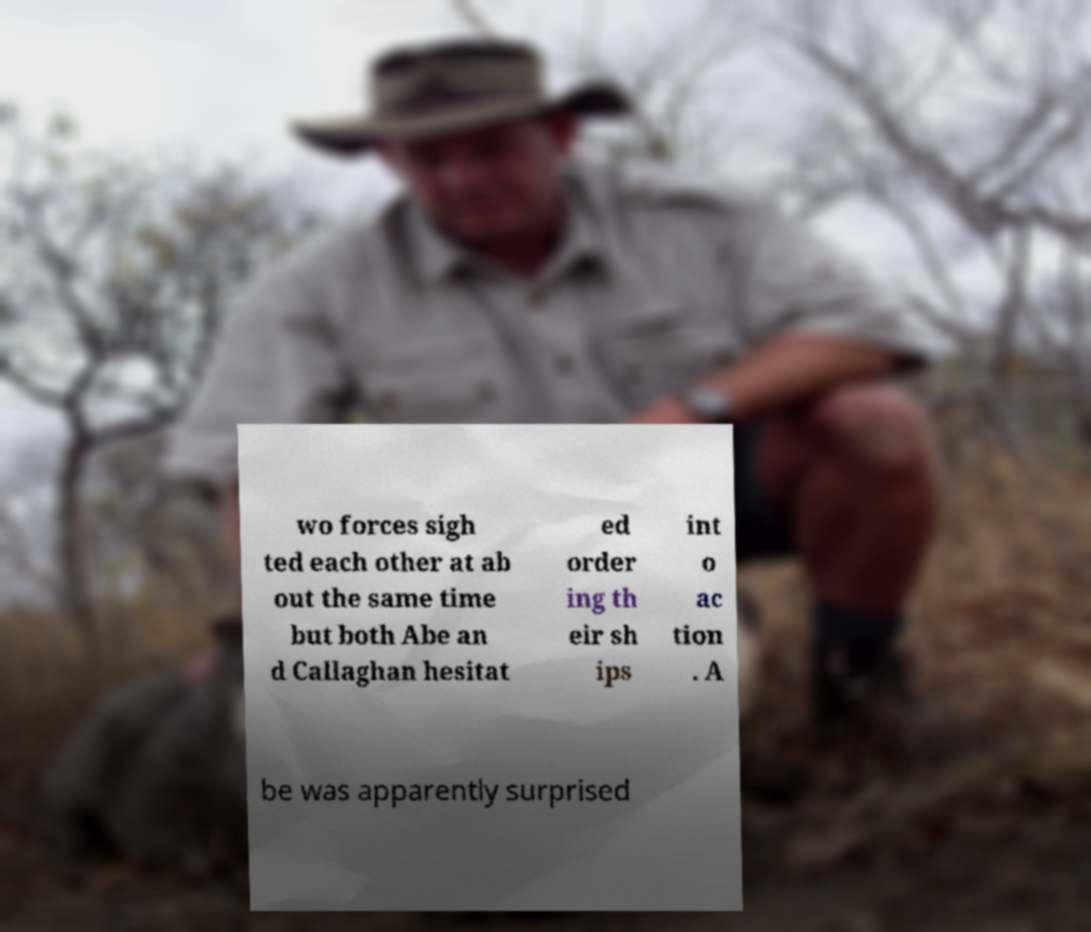Can you accurately transcribe the text from the provided image for me? wo forces sigh ted each other at ab out the same time but both Abe an d Callaghan hesitat ed order ing th eir sh ips int o ac tion . A be was apparently surprised 